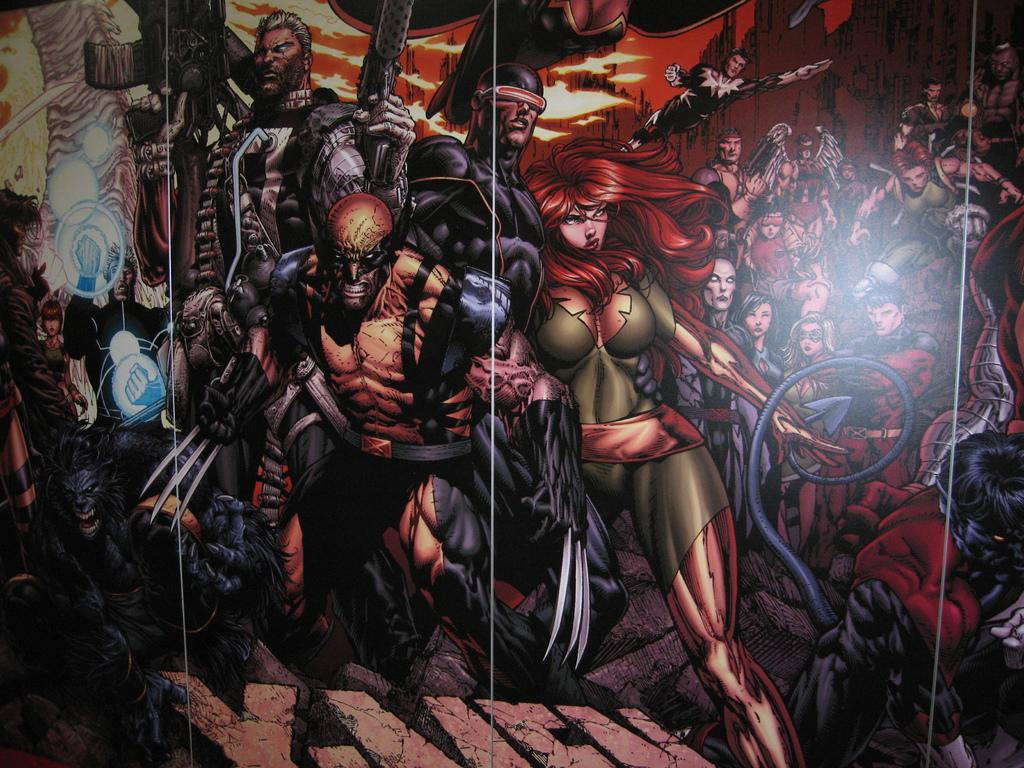What type of image is being described? The image is graphical in nature. What specific elements can be found in the image? There are cartoons present in the image. What type of lace can be seen on the cartoon character's clothing in the image? There is no lace present on any cartoon character's clothing in the image. How does the cartoon character smile in the image? The image does not depict a cartoon character smiling, as it only mentions the presence of cartoons in general. 